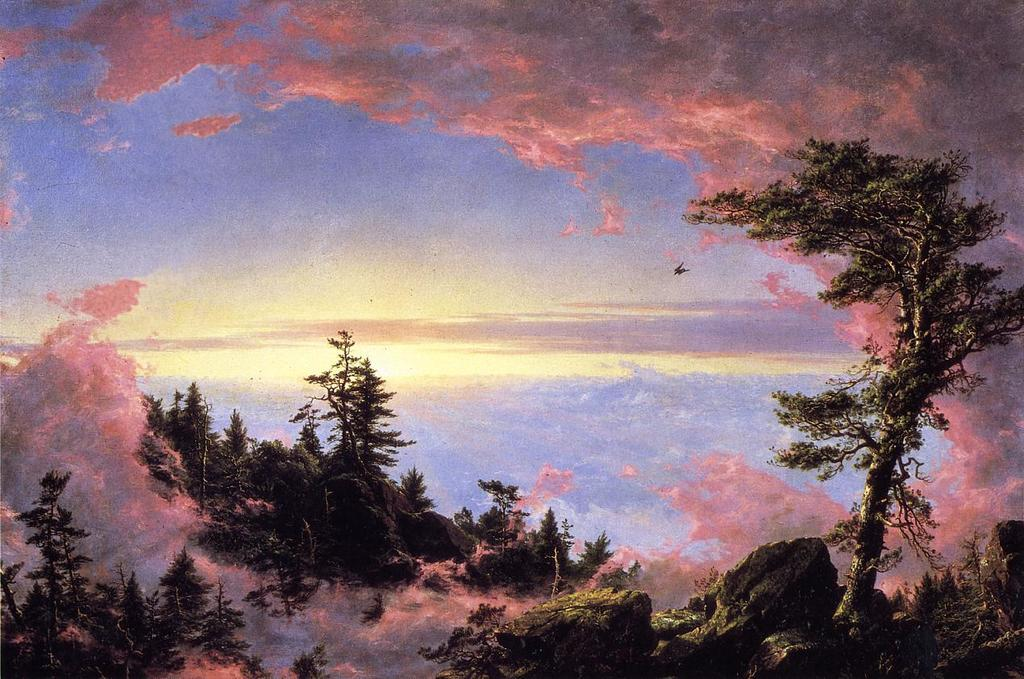What is the main subject of the image? There is a painting in the image. What elements are included in the painting? The painting contains trees and plants. How is the sky depicted in the painting? The painting depicts a cloudy sky. Can you tell me how many fans are visible in the painting? There are no fans present in the painting; it depicts trees, plants, and a cloudy sky. What type of cactus can be seen in the painting? There are no cacti depicted in the painting; it features trees and plants, but no specific mention of cacti. 